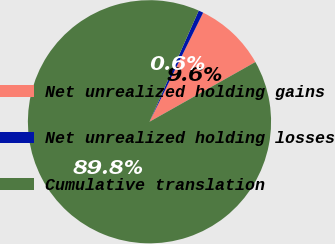Convert chart. <chart><loc_0><loc_0><loc_500><loc_500><pie_chart><fcel>Net unrealized holding gains<fcel>Net unrealized holding losses<fcel>Cumulative translation<nl><fcel>9.55%<fcel>0.64%<fcel>89.81%<nl></chart> 